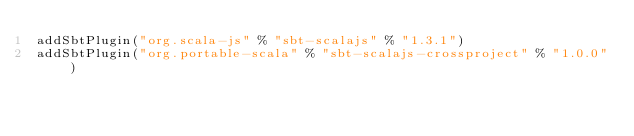<code> <loc_0><loc_0><loc_500><loc_500><_Scala_>addSbtPlugin("org.scala-js" % "sbt-scalajs" % "1.3.1")
addSbtPlugin("org.portable-scala" % "sbt-scalajs-crossproject" % "1.0.0")
</code> 